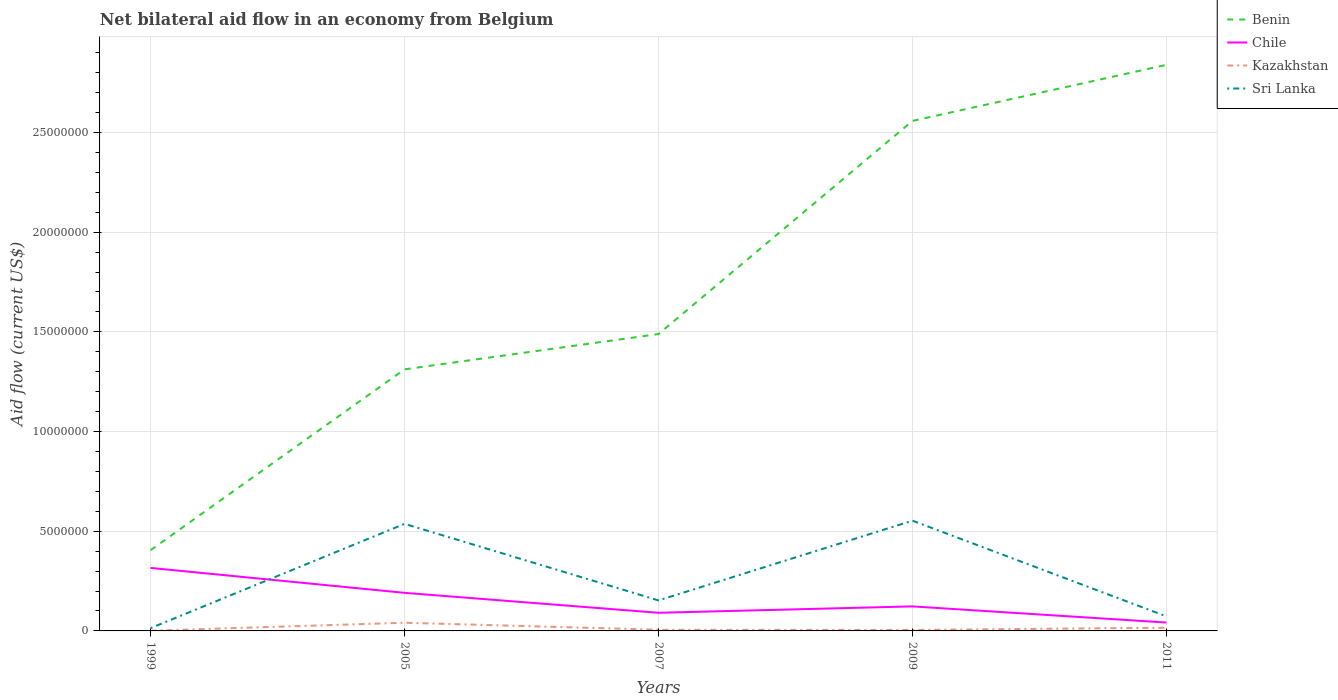Is the number of lines equal to the number of legend labels?
Offer a terse response. Yes. What is the total net bilateral aid flow in Chile in the graph?
Provide a succinct answer. 1.93e+06. What is the difference between the highest and the second highest net bilateral aid flow in Benin?
Offer a very short reply. 2.43e+07. What is the difference between two consecutive major ticks on the Y-axis?
Your answer should be very brief. 5.00e+06. Are the values on the major ticks of Y-axis written in scientific E-notation?
Offer a very short reply. No. Does the graph contain any zero values?
Offer a terse response. No. What is the title of the graph?
Keep it short and to the point. Net bilateral aid flow in an economy from Belgium. What is the label or title of the Y-axis?
Keep it short and to the point. Aid flow (current US$). What is the Aid flow (current US$) in Benin in 1999?
Offer a terse response. 4.05e+06. What is the Aid flow (current US$) of Chile in 1999?
Your answer should be very brief. 3.16e+06. What is the Aid flow (current US$) in Kazakhstan in 1999?
Make the answer very short. 10000. What is the Aid flow (current US$) of Benin in 2005?
Your answer should be compact. 1.31e+07. What is the Aid flow (current US$) in Chile in 2005?
Provide a succinct answer. 1.91e+06. What is the Aid flow (current US$) of Kazakhstan in 2005?
Provide a succinct answer. 4.10e+05. What is the Aid flow (current US$) of Sri Lanka in 2005?
Your response must be concise. 5.37e+06. What is the Aid flow (current US$) of Benin in 2007?
Make the answer very short. 1.49e+07. What is the Aid flow (current US$) of Chile in 2007?
Keep it short and to the point. 9.10e+05. What is the Aid flow (current US$) in Kazakhstan in 2007?
Make the answer very short. 6.00e+04. What is the Aid flow (current US$) of Sri Lanka in 2007?
Offer a terse response. 1.53e+06. What is the Aid flow (current US$) in Benin in 2009?
Provide a short and direct response. 2.56e+07. What is the Aid flow (current US$) of Chile in 2009?
Your answer should be very brief. 1.23e+06. What is the Aid flow (current US$) in Kazakhstan in 2009?
Keep it short and to the point. 5.00e+04. What is the Aid flow (current US$) of Sri Lanka in 2009?
Your answer should be compact. 5.53e+06. What is the Aid flow (current US$) of Benin in 2011?
Make the answer very short. 2.84e+07. What is the Aid flow (current US$) in Chile in 2011?
Provide a succinct answer. 4.20e+05. What is the Aid flow (current US$) in Kazakhstan in 2011?
Provide a short and direct response. 1.60e+05. What is the Aid flow (current US$) in Sri Lanka in 2011?
Offer a terse response. 7.30e+05. Across all years, what is the maximum Aid flow (current US$) of Benin?
Your response must be concise. 2.84e+07. Across all years, what is the maximum Aid flow (current US$) in Chile?
Your answer should be very brief. 3.16e+06. Across all years, what is the maximum Aid flow (current US$) of Sri Lanka?
Offer a terse response. 5.53e+06. Across all years, what is the minimum Aid flow (current US$) in Benin?
Your response must be concise. 4.05e+06. Across all years, what is the minimum Aid flow (current US$) in Chile?
Your answer should be very brief. 4.20e+05. What is the total Aid flow (current US$) of Benin in the graph?
Ensure brevity in your answer.  8.60e+07. What is the total Aid flow (current US$) of Chile in the graph?
Provide a short and direct response. 7.63e+06. What is the total Aid flow (current US$) of Kazakhstan in the graph?
Give a very brief answer. 6.90e+05. What is the total Aid flow (current US$) of Sri Lanka in the graph?
Offer a very short reply. 1.33e+07. What is the difference between the Aid flow (current US$) in Benin in 1999 and that in 2005?
Offer a very short reply. -9.07e+06. What is the difference between the Aid flow (current US$) in Chile in 1999 and that in 2005?
Your answer should be compact. 1.25e+06. What is the difference between the Aid flow (current US$) of Kazakhstan in 1999 and that in 2005?
Your response must be concise. -4.00e+05. What is the difference between the Aid flow (current US$) of Sri Lanka in 1999 and that in 2005?
Make the answer very short. -5.23e+06. What is the difference between the Aid flow (current US$) in Benin in 1999 and that in 2007?
Offer a very short reply. -1.08e+07. What is the difference between the Aid flow (current US$) of Chile in 1999 and that in 2007?
Provide a succinct answer. 2.25e+06. What is the difference between the Aid flow (current US$) of Sri Lanka in 1999 and that in 2007?
Give a very brief answer. -1.39e+06. What is the difference between the Aid flow (current US$) in Benin in 1999 and that in 2009?
Offer a very short reply. -2.15e+07. What is the difference between the Aid flow (current US$) in Chile in 1999 and that in 2009?
Offer a very short reply. 1.93e+06. What is the difference between the Aid flow (current US$) of Sri Lanka in 1999 and that in 2009?
Your answer should be very brief. -5.39e+06. What is the difference between the Aid flow (current US$) of Benin in 1999 and that in 2011?
Your response must be concise. -2.43e+07. What is the difference between the Aid flow (current US$) of Chile in 1999 and that in 2011?
Give a very brief answer. 2.74e+06. What is the difference between the Aid flow (current US$) in Kazakhstan in 1999 and that in 2011?
Your response must be concise. -1.50e+05. What is the difference between the Aid flow (current US$) in Sri Lanka in 1999 and that in 2011?
Ensure brevity in your answer.  -5.90e+05. What is the difference between the Aid flow (current US$) in Benin in 2005 and that in 2007?
Make the answer very short. -1.77e+06. What is the difference between the Aid flow (current US$) in Chile in 2005 and that in 2007?
Keep it short and to the point. 1.00e+06. What is the difference between the Aid flow (current US$) of Kazakhstan in 2005 and that in 2007?
Ensure brevity in your answer.  3.50e+05. What is the difference between the Aid flow (current US$) of Sri Lanka in 2005 and that in 2007?
Give a very brief answer. 3.84e+06. What is the difference between the Aid flow (current US$) in Benin in 2005 and that in 2009?
Your response must be concise. -1.25e+07. What is the difference between the Aid flow (current US$) of Chile in 2005 and that in 2009?
Provide a short and direct response. 6.80e+05. What is the difference between the Aid flow (current US$) of Kazakhstan in 2005 and that in 2009?
Your answer should be very brief. 3.60e+05. What is the difference between the Aid flow (current US$) of Benin in 2005 and that in 2011?
Your response must be concise. -1.53e+07. What is the difference between the Aid flow (current US$) of Chile in 2005 and that in 2011?
Your answer should be very brief. 1.49e+06. What is the difference between the Aid flow (current US$) in Kazakhstan in 2005 and that in 2011?
Ensure brevity in your answer.  2.50e+05. What is the difference between the Aid flow (current US$) in Sri Lanka in 2005 and that in 2011?
Make the answer very short. 4.64e+06. What is the difference between the Aid flow (current US$) in Benin in 2007 and that in 2009?
Your answer should be compact. -1.07e+07. What is the difference between the Aid flow (current US$) in Chile in 2007 and that in 2009?
Your answer should be compact. -3.20e+05. What is the difference between the Aid flow (current US$) of Kazakhstan in 2007 and that in 2009?
Keep it short and to the point. 10000. What is the difference between the Aid flow (current US$) of Sri Lanka in 2007 and that in 2009?
Give a very brief answer. -4.00e+06. What is the difference between the Aid flow (current US$) in Benin in 2007 and that in 2011?
Make the answer very short. -1.35e+07. What is the difference between the Aid flow (current US$) of Kazakhstan in 2007 and that in 2011?
Keep it short and to the point. -1.00e+05. What is the difference between the Aid flow (current US$) of Benin in 2009 and that in 2011?
Make the answer very short. -2.81e+06. What is the difference between the Aid flow (current US$) of Chile in 2009 and that in 2011?
Offer a very short reply. 8.10e+05. What is the difference between the Aid flow (current US$) in Sri Lanka in 2009 and that in 2011?
Provide a short and direct response. 4.80e+06. What is the difference between the Aid flow (current US$) in Benin in 1999 and the Aid flow (current US$) in Chile in 2005?
Keep it short and to the point. 2.14e+06. What is the difference between the Aid flow (current US$) in Benin in 1999 and the Aid flow (current US$) in Kazakhstan in 2005?
Offer a very short reply. 3.64e+06. What is the difference between the Aid flow (current US$) in Benin in 1999 and the Aid flow (current US$) in Sri Lanka in 2005?
Keep it short and to the point. -1.32e+06. What is the difference between the Aid flow (current US$) of Chile in 1999 and the Aid flow (current US$) of Kazakhstan in 2005?
Make the answer very short. 2.75e+06. What is the difference between the Aid flow (current US$) in Chile in 1999 and the Aid flow (current US$) in Sri Lanka in 2005?
Give a very brief answer. -2.21e+06. What is the difference between the Aid flow (current US$) in Kazakhstan in 1999 and the Aid flow (current US$) in Sri Lanka in 2005?
Offer a very short reply. -5.36e+06. What is the difference between the Aid flow (current US$) of Benin in 1999 and the Aid flow (current US$) of Chile in 2007?
Give a very brief answer. 3.14e+06. What is the difference between the Aid flow (current US$) of Benin in 1999 and the Aid flow (current US$) of Kazakhstan in 2007?
Make the answer very short. 3.99e+06. What is the difference between the Aid flow (current US$) in Benin in 1999 and the Aid flow (current US$) in Sri Lanka in 2007?
Your response must be concise. 2.52e+06. What is the difference between the Aid flow (current US$) of Chile in 1999 and the Aid flow (current US$) of Kazakhstan in 2007?
Provide a short and direct response. 3.10e+06. What is the difference between the Aid flow (current US$) in Chile in 1999 and the Aid flow (current US$) in Sri Lanka in 2007?
Keep it short and to the point. 1.63e+06. What is the difference between the Aid flow (current US$) of Kazakhstan in 1999 and the Aid flow (current US$) of Sri Lanka in 2007?
Provide a succinct answer. -1.52e+06. What is the difference between the Aid flow (current US$) of Benin in 1999 and the Aid flow (current US$) of Chile in 2009?
Keep it short and to the point. 2.82e+06. What is the difference between the Aid flow (current US$) in Benin in 1999 and the Aid flow (current US$) in Kazakhstan in 2009?
Give a very brief answer. 4.00e+06. What is the difference between the Aid flow (current US$) of Benin in 1999 and the Aid flow (current US$) of Sri Lanka in 2009?
Offer a very short reply. -1.48e+06. What is the difference between the Aid flow (current US$) in Chile in 1999 and the Aid flow (current US$) in Kazakhstan in 2009?
Keep it short and to the point. 3.11e+06. What is the difference between the Aid flow (current US$) in Chile in 1999 and the Aid flow (current US$) in Sri Lanka in 2009?
Offer a very short reply. -2.37e+06. What is the difference between the Aid flow (current US$) of Kazakhstan in 1999 and the Aid flow (current US$) of Sri Lanka in 2009?
Offer a terse response. -5.52e+06. What is the difference between the Aid flow (current US$) of Benin in 1999 and the Aid flow (current US$) of Chile in 2011?
Your response must be concise. 3.63e+06. What is the difference between the Aid flow (current US$) in Benin in 1999 and the Aid flow (current US$) in Kazakhstan in 2011?
Make the answer very short. 3.89e+06. What is the difference between the Aid flow (current US$) in Benin in 1999 and the Aid flow (current US$) in Sri Lanka in 2011?
Offer a very short reply. 3.32e+06. What is the difference between the Aid flow (current US$) in Chile in 1999 and the Aid flow (current US$) in Sri Lanka in 2011?
Your response must be concise. 2.43e+06. What is the difference between the Aid flow (current US$) in Kazakhstan in 1999 and the Aid flow (current US$) in Sri Lanka in 2011?
Provide a short and direct response. -7.20e+05. What is the difference between the Aid flow (current US$) in Benin in 2005 and the Aid flow (current US$) in Chile in 2007?
Make the answer very short. 1.22e+07. What is the difference between the Aid flow (current US$) of Benin in 2005 and the Aid flow (current US$) of Kazakhstan in 2007?
Ensure brevity in your answer.  1.31e+07. What is the difference between the Aid flow (current US$) of Benin in 2005 and the Aid flow (current US$) of Sri Lanka in 2007?
Your answer should be compact. 1.16e+07. What is the difference between the Aid flow (current US$) of Chile in 2005 and the Aid flow (current US$) of Kazakhstan in 2007?
Provide a short and direct response. 1.85e+06. What is the difference between the Aid flow (current US$) of Chile in 2005 and the Aid flow (current US$) of Sri Lanka in 2007?
Your answer should be very brief. 3.80e+05. What is the difference between the Aid flow (current US$) in Kazakhstan in 2005 and the Aid flow (current US$) in Sri Lanka in 2007?
Offer a very short reply. -1.12e+06. What is the difference between the Aid flow (current US$) in Benin in 2005 and the Aid flow (current US$) in Chile in 2009?
Keep it short and to the point. 1.19e+07. What is the difference between the Aid flow (current US$) in Benin in 2005 and the Aid flow (current US$) in Kazakhstan in 2009?
Make the answer very short. 1.31e+07. What is the difference between the Aid flow (current US$) in Benin in 2005 and the Aid flow (current US$) in Sri Lanka in 2009?
Make the answer very short. 7.59e+06. What is the difference between the Aid flow (current US$) in Chile in 2005 and the Aid flow (current US$) in Kazakhstan in 2009?
Offer a terse response. 1.86e+06. What is the difference between the Aid flow (current US$) in Chile in 2005 and the Aid flow (current US$) in Sri Lanka in 2009?
Offer a terse response. -3.62e+06. What is the difference between the Aid flow (current US$) of Kazakhstan in 2005 and the Aid flow (current US$) of Sri Lanka in 2009?
Ensure brevity in your answer.  -5.12e+06. What is the difference between the Aid flow (current US$) in Benin in 2005 and the Aid flow (current US$) in Chile in 2011?
Provide a succinct answer. 1.27e+07. What is the difference between the Aid flow (current US$) in Benin in 2005 and the Aid flow (current US$) in Kazakhstan in 2011?
Make the answer very short. 1.30e+07. What is the difference between the Aid flow (current US$) of Benin in 2005 and the Aid flow (current US$) of Sri Lanka in 2011?
Give a very brief answer. 1.24e+07. What is the difference between the Aid flow (current US$) of Chile in 2005 and the Aid flow (current US$) of Kazakhstan in 2011?
Make the answer very short. 1.75e+06. What is the difference between the Aid flow (current US$) of Chile in 2005 and the Aid flow (current US$) of Sri Lanka in 2011?
Ensure brevity in your answer.  1.18e+06. What is the difference between the Aid flow (current US$) of Kazakhstan in 2005 and the Aid flow (current US$) of Sri Lanka in 2011?
Give a very brief answer. -3.20e+05. What is the difference between the Aid flow (current US$) of Benin in 2007 and the Aid flow (current US$) of Chile in 2009?
Your answer should be very brief. 1.37e+07. What is the difference between the Aid flow (current US$) of Benin in 2007 and the Aid flow (current US$) of Kazakhstan in 2009?
Ensure brevity in your answer.  1.48e+07. What is the difference between the Aid flow (current US$) in Benin in 2007 and the Aid flow (current US$) in Sri Lanka in 2009?
Offer a very short reply. 9.36e+06. What is the difference between the Aid flow (current US$) in Chile in 2007 and the Aid flow (current US$) in Kazakhstan in 2009?
Your response must be concise. 8.60e+05. What is the difference between the Aid flow (current US$) in Chile in 2007 and the Aid flow (current US$) in Sri Lanka in 2009?
Your answer should be compact. -4.62e+06. What is the difference between the Aid flow (current US$) of Kazakhstan in 2007 and the Aid flow (current US$) of Sri Lanka in 2009?
Offer a very short reply. -5.47e+06. What is the difference between the Aid flow (current US$) of Benin in 2007 and the Aid flow (current US$) of Chile in 2011?
Your answer should be compact. 1.45e+07. What is the difference between the Aid flow (current US$) of Benin in 2007 and the Aid flow (current US$) of Kazakhstan in 2011?
Your response must be concise. 1.47e+07. What is the difference between the Aid flow (current US$) in Benin in 2007 and the Aid flow (current US$) in Sri Lanka in 2011?
Provide a succinct answer. 1.42e+07. What is the difference between the Aid flow (current US$) in Chile in 2007 and the Aid flow (current US$) in Kazakhstan in 2011?
Give a very brief answer. 7.50e+05. What is the difference between the Aid flow (current US$) of Chile in 2007 and the Aid flow (current US$) of Sri Lanka in 2011?
Offer a very short reply. 1.80e+05. What is the difference between the Aid flow (current US$) of Kazakhstan in 2007 and the Aid flow (current US$) of Sri Lanka in 2011?
Your answer should be compact. -6.70e+05. What is the difference between the Aid flow (current US$) in Benin in 2009 and the Aid flow (current US$) in Chile in 2011?
Provide a short and direct response. 2.52e+07. What is the difference between the Aid flow (current US$) of Benin in 2009 and the Aid flow (current US$) of Kazakhstan in 2011?
Keep it short and to the point. 2.54e+07. What is the difference between the Aid flow (current US$) of Benin in 2009 and the Aid flow (current US$) of Sri Lanka in 2011?
Provide a short and direct response. 2.48e+07. What is the difference between the Aid flow (current US$) in Chile in 2009 and the Aid flow (current US$) in Kazakhstan in 2011?
Make the answer very short. 1.07e+06. What is the difference between the Aid flow (current US$) in Kazakhstan in 2009 and the Aid flow (current US$) in Sri Lanka in 2011?
Offer a very short reply. -6.80e+05. What is the average Aid flow (current US$) of Benin per year?
Provide a succinct answer. 1.72e+07. What is the average Aid flow (current US$) of Chile per year?
Provide a succinct answer. 1.53e+06. What is the average Aid flow (current US$) of Kazakhstan per year?
Your answer should be very brief. 1.38e+05. What is the average Aid flow (current US$) of Sri Lanka per year?
Keep it short and to the point. 2.66e+06. In the year 1999, what is the difference between the Aid flow (current US$) in Benin and Aid flow (current US$) in Chile?
Make the answer very short. 8.90e+05. In the year 1999, what is the difference between the Aid flow (current US$) of Benin and Aid flow (current US$) of Kazakhstan?
Your answer should be very brief. 4.04e+06. In the year 1999, what is the difference between the Aid flow (current US$) of Benin and Aid flow (current US$) of Sri Lanka?
Offer a very short reply. 3.91e+06. In the year 1999, what is the difference between the Aid flow (current US$) in Chile and Aid flow (current US$) in Kazakhstan?
Your response must be concise. 3.15e+06. In the year 1999, what is the difference between the Aid flow (current US$) in Chile and Aid flow (current US$) in Sri Lanka?
Provide a short and direct response. 3.02e+06. In the year 2005, what is the difference between the Aid flow (current US$) in Benin and Aid flow (current US$) in Chile?
Provide a succinct answer. 1.12e+07. In the year 2005, what is the difference between the Aid flow (current US$) in Benin and Aid flow (current US$) in Kazakhstan?
Give a very brief answer. 1.27e+07. In the year 2005, what is the difference between the Aid flow (current US$) of Benin and Aid flow (current US$) of Sri Lanka?
Keep it short and to the point. 7.75e+06. In the year 2005, what is the difference between the Aid flow (current US$) in Chile and Aid flow (current US$) in Kazakhstan?
Your answer should be compact. 1.50e+06. In the year 2005, what is the difference between the Aid flow (current US$) in Chile and Aid flow (current US$) in Sri Lanka?
Provide a short and direct response. -3.46e+06. In the year 2005, what is the difference between the Aid flow (current US$) in Kazakhstan and Aid flow (current US$) in Sri Lanka?
Give a very brief answer. -4.96e+06. In the year 2007, what is the difference between the Aid flow (current US$) in Benin and Aid flow (current US$) in Chile?
Provide a succinct answer. 1.40e+07. In the year 2007, what is the difference between the Aid flow (current US$) of Benin and Aid flow (current US$) of Kazakhstan?
Your answer should be very brief. 1.48e+07. In the year 2007, what is the difference between the Aid flow (current US$) in Benin and Aid flow (current US$) in Sri Lanka?
Keep it short and to the point. 1.34e+07. In the year 2007, what is the difference between the Aid flow (current US$) of Chile and Aid flow (current US$) of Kazakhstan?
Keep it short and to the point. 8.50e+05. In the year 2007, what is the difference between the Aid flow (current US$) in Chile and Aid flow (current US$) in Sri Lanka?
Give a very brief answer. -6.20e+05. In the year 2007, what is the difference between the Aid flow (current US$) of Kazakhstan and Aid flow (current US$) of Sri Lanka?
Your answer should be compact. -1.47e+06. In the year 2009, what is the difference between the Aid flow (current US$) of Benin and Aid flow (current US$) of Chile?
Offer a very short reply. 2.44e+07. In the year 2009, what is the difference between the Aid flow (current US$) in Benin and Aid flow (current US$) in Kazakhstan?
Offer a very short reply. 2.55e+07. In the year 2009, what is the difference between the Aid flow (current US$) of Benin and Aid flow (current US$) of Sri Lanka?
Provide a short and direct response. 2.00e+07. In the year 2009, what is the difference between the Aid flow (current US$) of Chile and Aid flow (current US$) of Kazakhstan?
Your answer should be compact. 1.18e+06. In the year 2009, what is the difference between the Aid flow (current US$) in Chile and Aid flow (current US$) in Sri Lanka?
Your answer should be very brief. -4.30e+06. In the year 2009, what is the difference between the Aid flow (current US$) in Kazakhstan and Aid flow (current US$) in Sri Lanka?
Keep it short and to the point. -5.48e+06. In the year 2011, what is the difference between the Aid flow (current US$) of Benin and Aid flow (current US$) of Chile?
Your answer should be very brief. 2.80e+07. In the year 2011, what is the difference between the Aid flow (current US$) in Benin and Aid flow (current US$) in Kazakhstan?
Keep it short and to the point. 2.82e+07. In the year 2011, what is the difference between the Aid flow (current US$) in Benin and Aid flow (current US$) in Sri Lanka?
Your answer should be compact. 2.77e+07. In the year 2011, what is the difference between the Aid flow (current US$) in Chile and Aid flow (current US$) in Sri Lanka?
Your answer should be very brief. -3.10e+05. In the year 2011, what is the difference between the Aid flow (current US$) of Kazakhstan and Aid flow (current US$) of Sri Lanka?
Ensure brevity in your answer.  -5.70e+05. What is the ratio of the Aid flow (current US$) in Benin in 1999 to that in 2005?
Offer a very short reply. 0.31. What is the ratio of the Aid flow (current US$) of Chile in 1999 to that in 2005?
Keep it short and to the point. 1.65. What is the ratio of the Aid flow (current US$) of Kazakhstan in 1999 to that in 2005?
Ensure brevity in your answer.  0.02. What is the ratio of the Aid flow (current US$) in Sri Lanka in 1999 to that in 2005?
Your answer should be compact. 0.03. What is the ratio of the Aid flow (current US$) in Benin in 1999 to that in 2007?
Offer a very short reply. 0.27. What is the ratio of the Aid flow (current US$) in Chile in 1999 to that in 2007?
Provide a succinct answer. 3.47. What is the ratio of the Aid flow (current US$) in Sri Lanka in 1999 to that in 2007?
Make the answer very short. 0.09. What is the ratio of the Aid flow (current US$) of Benin in 1999 to that in 2009?
Your response must be concise. 0.16. What is the ratio of the Aid flow (current US$) in Chile in 1999 to that in 2009?
Offer a very short reply. 2.57. What is the ratio of the Aid flow (current US$) of Sri Lanka in 1999 to that in 2009?
Keep it short and to the point. 0.03. What is the ratio of the Aid flow (current US$) in Benin in 1999 to that in 2011?
Offer a very short reply. 0.14. What is the ratio of the Aid flow (current US$) in Chile in 1999 to that in 2011?
Provide a succinct answer. 7.52. What is the ratio of the Aid flow (current US$) in Kazakhstan in 1999 to that in 2011?
Keep it short and to the point. 0.06. What is the ratio of the Aid flow (current US$) of Sri Lanka in 1999 to that in 2011?
Your answer should be compact. 0.19. What is the ratio of the Aid flow (current US$) of Benin in 2005 to that in 2007?
Provide a succinct answer. 0.88. What is the ratio of the Aid flow (current US$) of Chile in 2005 to that in 2007?
Offer a terse response. 2.1. What is the ratio of the Aid flow (current US$) of Kazakhstan in 2005 to that in 2007?
Offer a terse response. 6.83. What is the ratio of the Aid flow (current US$) in Sri Lanka in 2005 to that in 2007?
Your answer should be compact. 3.51. What is the ratio of the Aid flow (current US$) in Benin in 2005 to that in 2009?
Offer a very short reply. 0.51. What is the ratio of the Aid flow (current US$) of Chile in 2005 to that in 2009?
Give a very brief answer. 1.55. What is the ratio of the Aid flow (current US$) in Kazakhstan in 2005 to that in 2009?
Provide a short and direct response. 8.2. What is the ratio of the Aid flow (current US$) in Sri Lanka in 2005 to that in 2009?
Give a very brief answer. 0.97. What is the ratio of the Aid flow (current US$) in Benin in 2005 to that in 2011?
Keep it short and to the point. 0.46. What is the ratio of the Aid flow (current US$) of Chile in 2005 to that in 2011?
Your response must be concise. 4.55. What is the ratio of the Aid flow (current US$) of Kazakhstan in 2005 to that in 2011?
Offer a very short reply. 2.56. What is the ratio of the Aid flow (current US$) in Sri Lanka in 2005 to that in 2011?
Make the answer very short. 7.36. What is the ratio of the Aid flow (current US$) in Benin in 2007 to that in 2009?
Your answer should be very brief. 0.58. What is the ratio of the Aid flow (current US$) in Chile in 2007 to that in 2009?
Offer a terse response. 0.74. What is the ratio of the Aid flow (current US$) in Sri Lanka in 2007 to that in 2009?
Offer a terse response. 0.28. What is the ratio of the Aid flow (current US$) in Benin in 2007 to that in 2011?
Provide a short and direct response. 0.52. What is the ratio of the Aid flow (current US$) in Chile in 2007 to that in 2011?
Offer a terse response. 2.17. What is the ratio of the Aid flow (current US$) in Kazakhstan in 2007 to that in 2011?
Provide a succinct answer. 0.38. What is the ratio of the Aid flow (current US$) in Sri Lanka in 2007 to that in 2011?
Ensure brevity in your answer.  2.1. What is the ratio of the Aid flow (current US$) in Benin in 2009 to that in 2011?
Your response must be concise. 0.9. What is the ratio of the Aid flow (current US$) in Chile in 2009 to that in 2011?
Provide a succinct answer. 2.93. What is the ratio of the Aid flow (current US$) in Kazakhstan in 2009 to that in 2011?
Ensure brevity in your answer.  0.31. What is the ratio of the Aid flow (current US$) in Sri Lanka in 2009 to that in 2011?
Offer a very short reply. 7.58. What is the difference between the highest and the second highest Aid flow (current US$) of Benin?
Ensure brevity in your answer.  2.81e+06. What is the difference between the highest and the second highest Aid flow (current US$) in Chile?
Keep it short and to the point. 1.25e+06. What is the difference between the highest and the second highest Aid flow (current US$) of Kazakhstan?
Your response must be concise. 2.50e+05. What is the difference between the highest and the second highest Aid flow (current US$) in Sri Lanka?
Ensure brevity in your answer.  1.60e+05. What is the difference between the highest and the lowest Aid flow (current US$) of Benin?
Keep it short and to the point. 2.43e+07. What is the difference between the highest and the lowest Aid flow (current US$) of Chile?
Your answer should be very brief. 2.74e+06. What is the difference between the highest and the lowest Aid flow (current US$) in Sri Lanka?
Your answer should be very brief. 5.39e+06. 